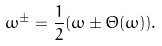<formula> <loc_0><loc_0><loc_500><loc_500>\omega ^ { \pm } = \frac { 1 } { 2 } ( \omega \pm \Theta ( \omega ) ) .</formula> 